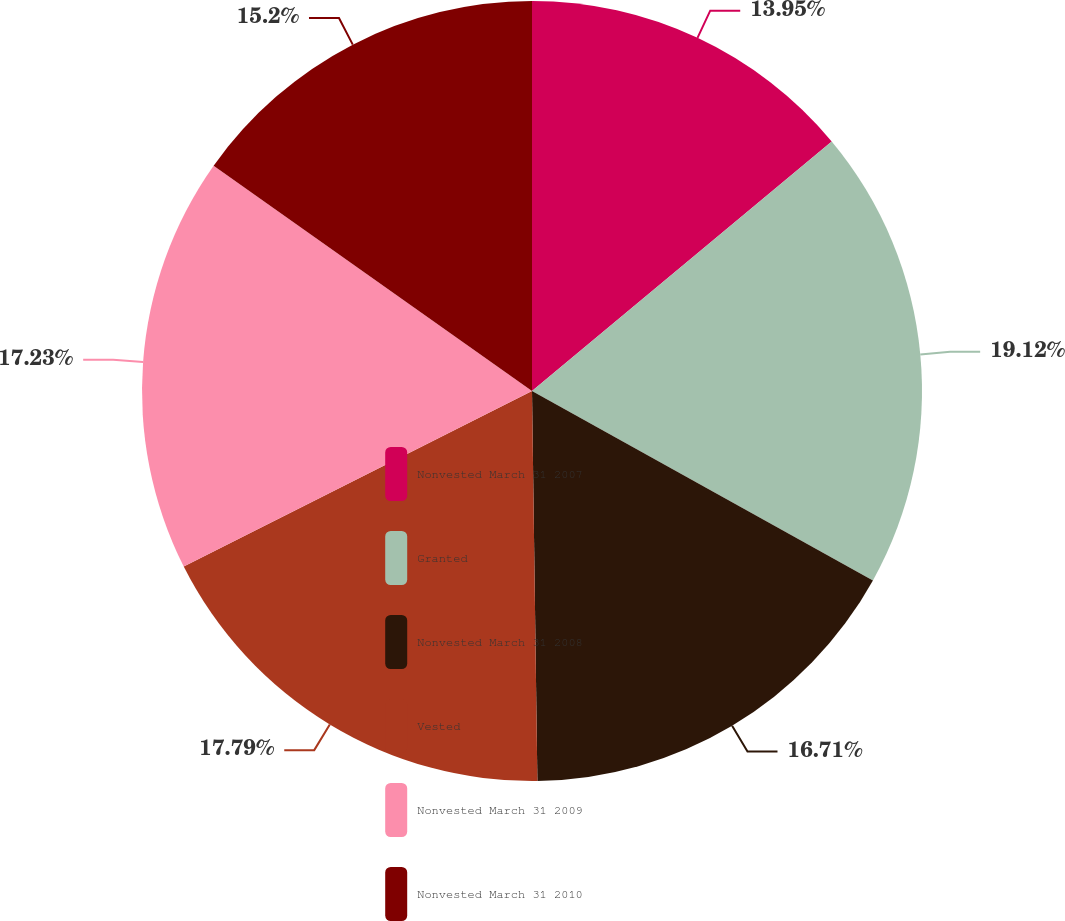Convert chart. <chart><loc_0><loc_0><loc_500><loc_500><pie_chart><fcel>Nonvested March 31 2007<fcel>Granted<fcel>Nonvested March 31 2008<fcel>Vested<fcel>Nonvested March 31 2009<fcel>Nonvested March 31 2010<nl><fcel>13.95%<fcel>19.12%<fcel>16.71%<fcel>17.79%<fcel>17.23%<fcel>15.2%<nl></chart> 